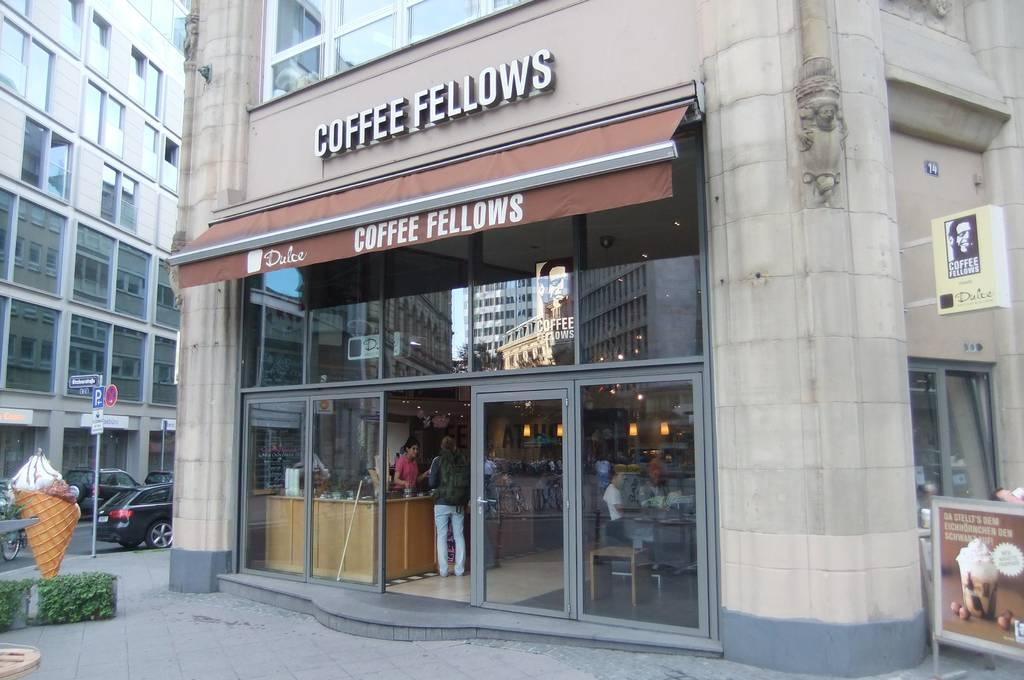What type of structures can be seen in the image? There are buildings in the image. Can you describe the activity inside the buildings? There are people inside the buildings. What are the boards beside the buildings used for? The boards beside the buildings are not described in the facts, so we cannot determine their purpose. How are the boards positioned in the image? There are boards on poles in the image. What type of transportation can be seen on the road? Vehicles are visible on the road. What type of vegetation is present in the image? Plants are present in the image. Are there any sheep committing crimes in the image? There is no mention of sheep or crimes in the image, so we cannot answer this question. What type of thrill can be experienced by the people inside the buildings? The facts do not provide information about the emotions or experiences of the people inside the buildings, so we cannot answer this question. 